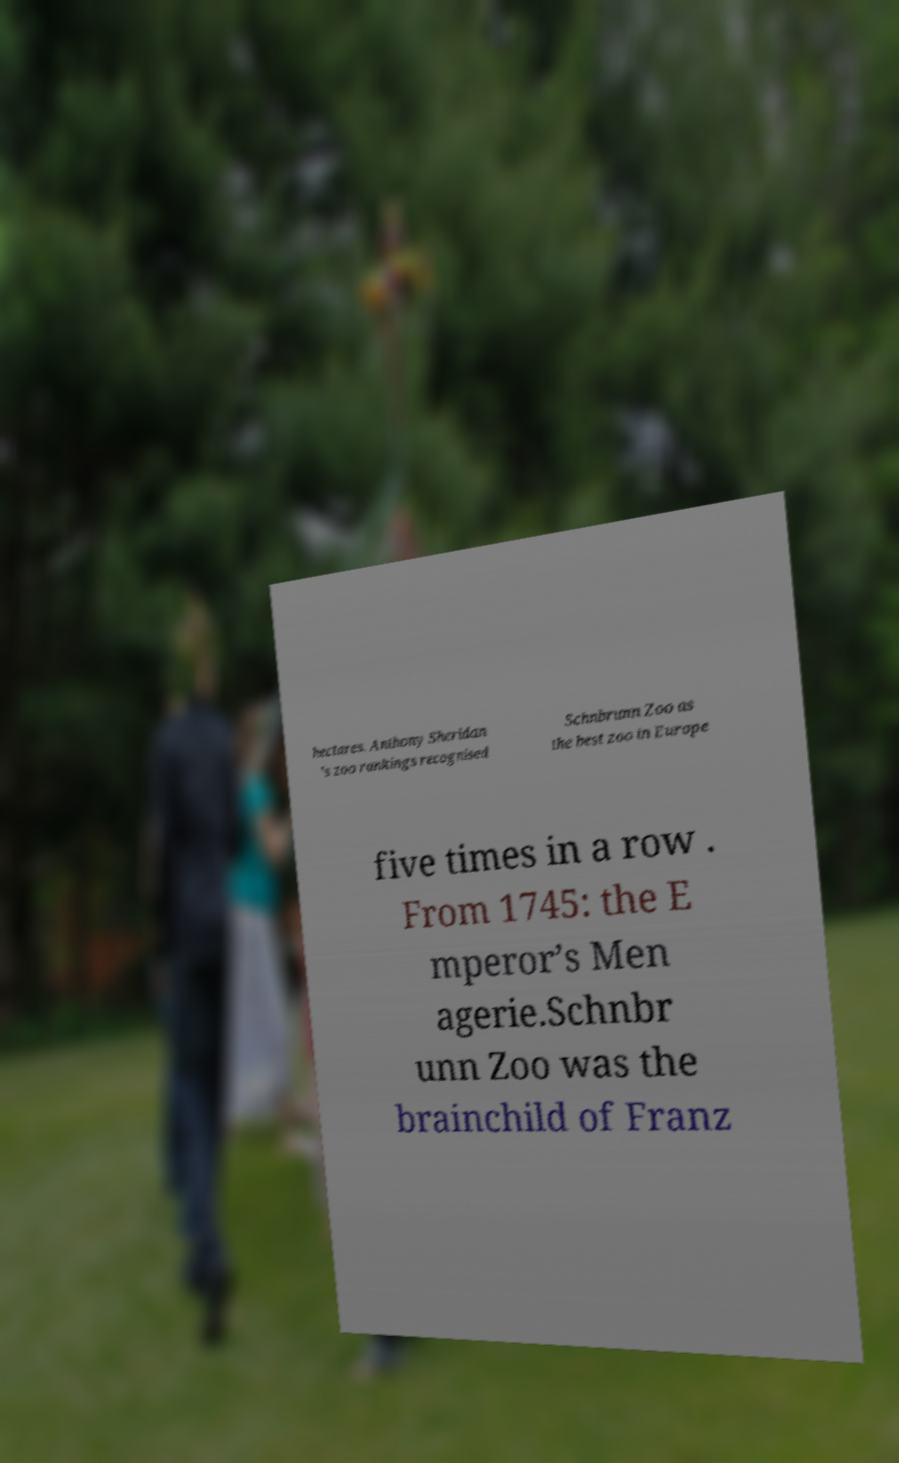I need the written content from this picture converted into text. Can you do that? hectares. Anthony Sheridan ’s zoo rankings recognised Schnbrunn Zoo as the best zoo in Europe five times in a row . From 1745: the E mperor’s Men agerie.Schnbr unn Zoo was the brainchild of Franz 